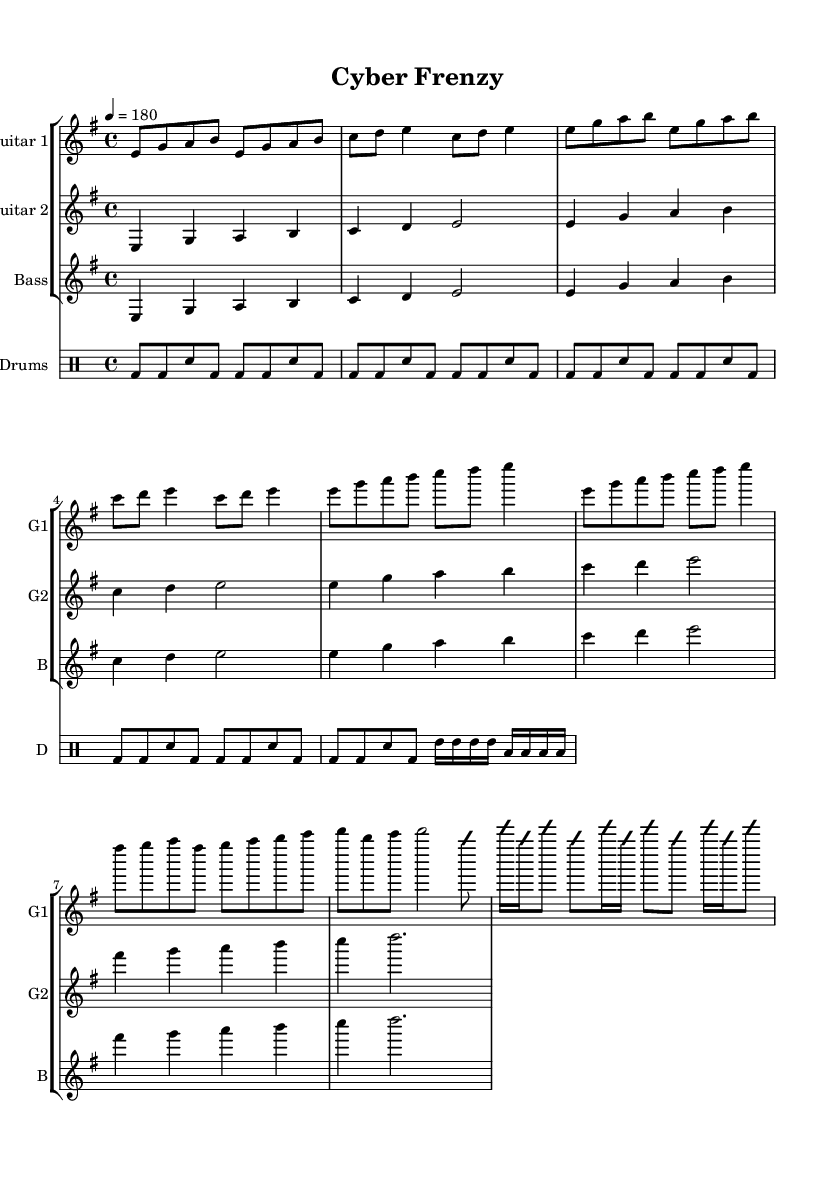What is the key signature of this music? The key signature indicated in the sheet music is one sharp, which corresponds to the key of E minor. This is determined by checking the key signature notation at the beginning of the score.
Answer: E minor What is the time signature of this piece? The time signature shown at the beginning of the sheet music is four-four, as indicated by the "4/4" notation. It signifies that there are four beats in each measure and the quarter note gets one beat.
Answer: 4/4 What is the tempo marking for this piece? The tempo marking at the beginning of the score states "4 = 180," which indicates the tempo is set to 180 beats per minute, making it a fast-paced track suitable for thrash metal.
Answer: 180 How many measures are there in the intro? The intro section consists of 2 measures, as counted from the notation in the sheet music specifically in the "Intro" part of the guitar one section.
Answer: 2 Which instrument plays the solo part? The instrument designated to play the solo part is Guitar 1, as indicated by the section labeled "Solo (simplified)" under the Guitar 1 staff in the sheet music.
Answer: Guitar 1 What rhythm does the bass guitar follow? The bass guitar follows a rhythm that matches the root notes of the chord progression, as evidenced by looking at the bass part which aligns with the root notes shown in the measure entries.
Answer: Root notes What type of drum pattern is primarily used? The drum pattern features a basic beat consisting mainly of bass drum hits (bd) and snare drum hits (sn), which are typically common in thrash metal styles to create a driving rhythm.
Answer: Basic beat 